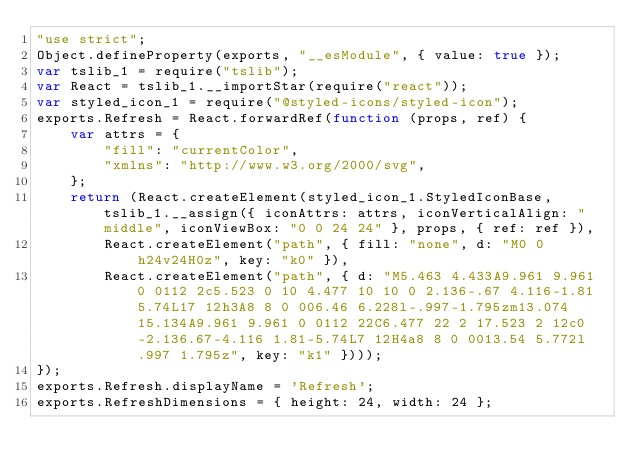Convert code to text. <code><loc_0><loc_0><loc_500><loc_500><_JavaScript_>"use strict";
Object.defineProperty(exports, "__esModule", { value: true });
var tslib_1 = require("tslib");
var React = tslib_1.__importStar(require("react"));
var styled_icon_1 = require("@styled-icons/styled-icon");
exports.Refresh = React.forwardRef(function (props, ref) {
    var attrs = {
        "fill": "currentColor",
        "xmlns": "http://www.w3.org/2000/svg",
    };
    return (React.createElement(styled_icon_1.StyledIconBase, tslib_1.__assign({ iconAttrs: attrs, iconVerticalAlign: "middle", iconViewBox: "0 0 24 24" }, props, { ref: ref }),
        React.createElement("path", { fill: "none", d: "M0 0h24v24H0z", key: "k0" }),
        React.createElement("path", { d: "M5.463 4.433A9.961 9.961 0 0112 2c5.523 0 10 4.477 10 10 0 2.136-.67 4.116-1.81 5.74L17 12h3A8 8 0 006.46 6.228l-.997-1.795zm13.074 15.134A9.961 9.961 0 0112 22C6.477 22 2 17.523 2 12c0-2.136.67-4.116 1.81-5.74L7 12H4a8 8 0 0013.54 5.772l.997 1.795z", key: "k1" })));
});
exports.Refresh.displayName = 'Refresh';
exports.RefreshDimensions = { height: 24, width: 24 };
</code> 